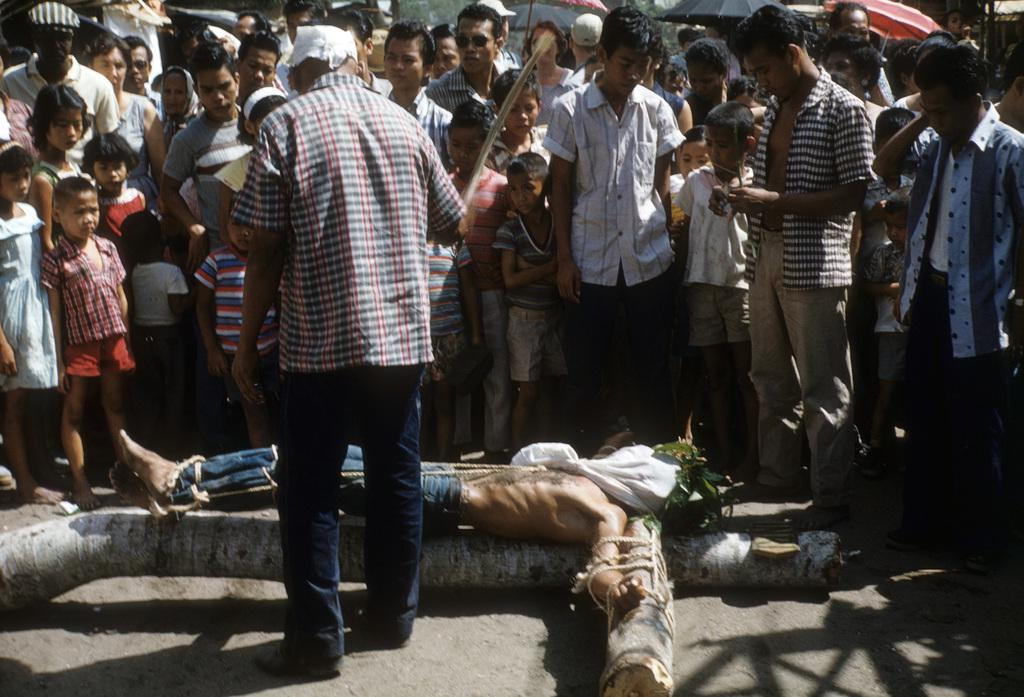What is the main subject of the image? There is a person in the image. What is the condition of the person in the image? The person is tied to a tree trunk. Are there any other people present in the image? Yes, there are other persons around the tied person. What type of ghost can be seen interacting with the tied person in the image? There is no ghost present in the image; it features a person tied to a tree trunk with other people around. What meal is being prepared by the tied person in the image? There is no meal preparation or reference to a meal in the image. 